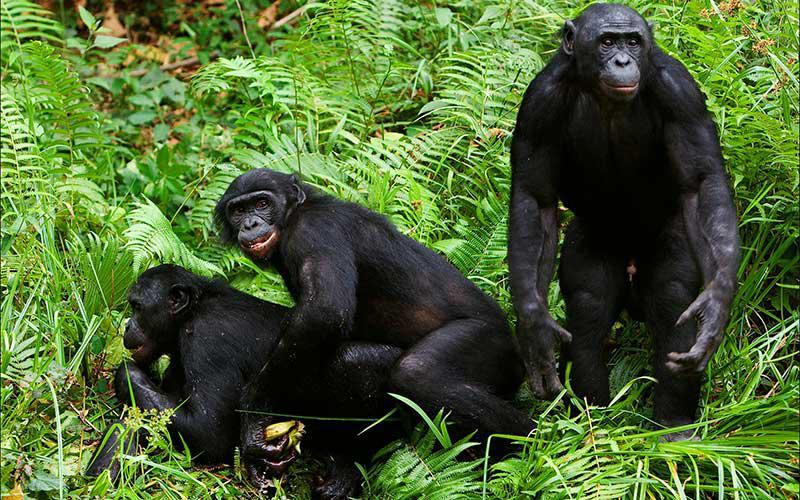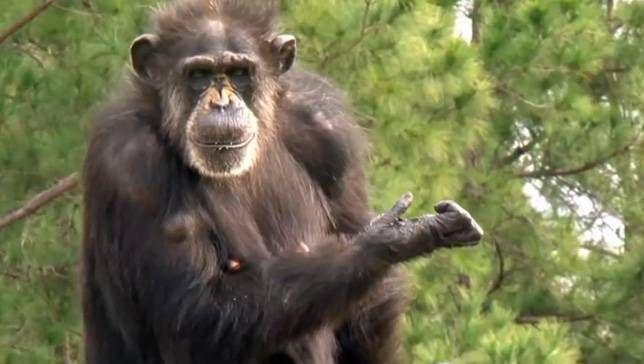The first image is the image on the left, the second image is the image on the right. Examine the images to the left and right. Is the description "At least one of the images contains exactly three monkeys." accurate? Answer yes or no. Yes. 